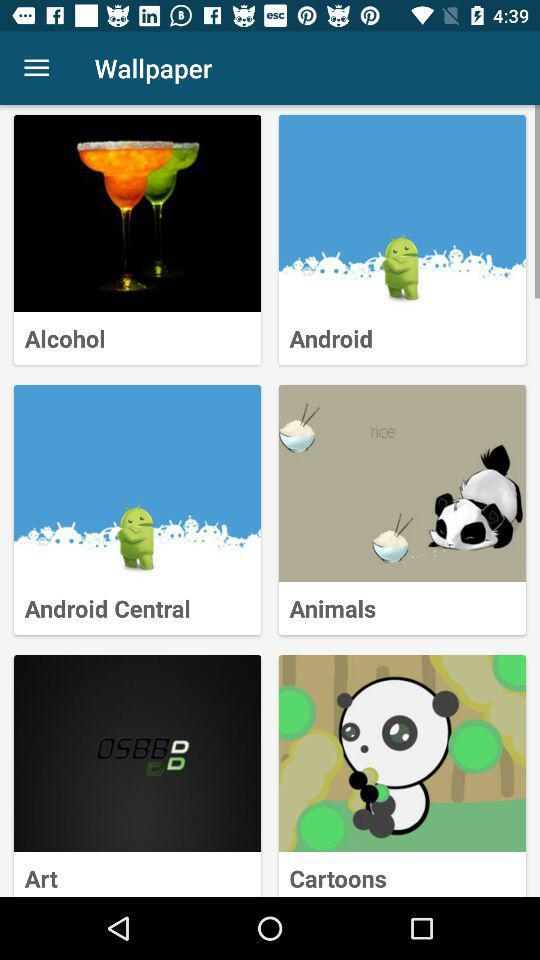What is the application name?
When the provided information is insufficient, respond with <no answer>. <no answer> 